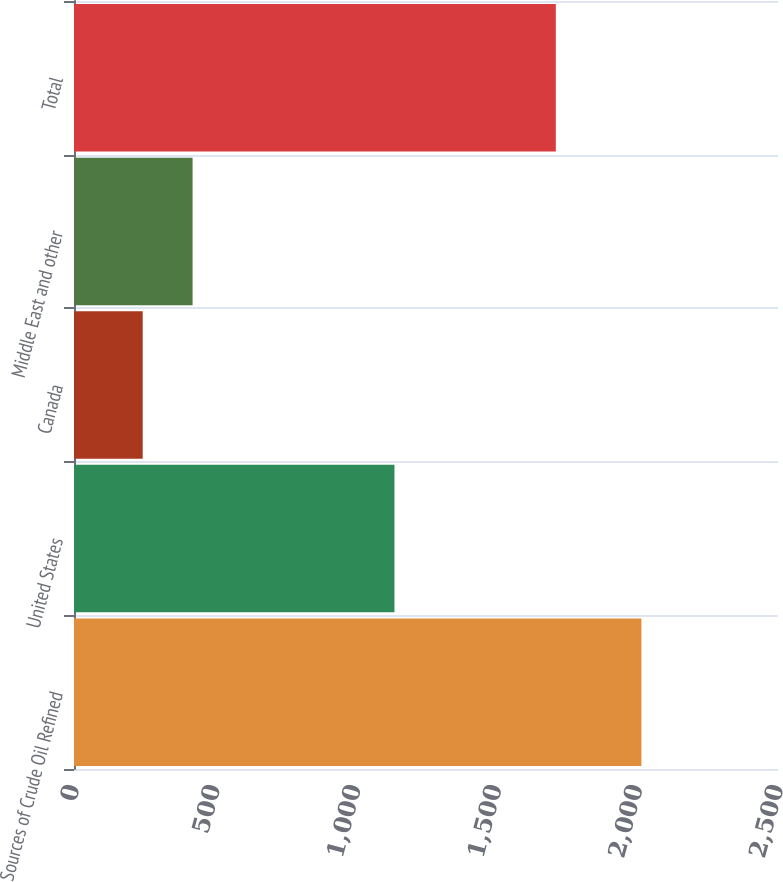Convert chart to OTSL. <chart><loc_0><loc_0><loc_500><loc_500><bar_chart><fcel>Sources of Crude Oil Refined<fcel>United States<fcel>Canada<fcel>Middle East and other<fcel>Total<nl><fcel>2015<fcel>1138<fcel>244<fcel>421.1<fcel>1711<nl></chart> 